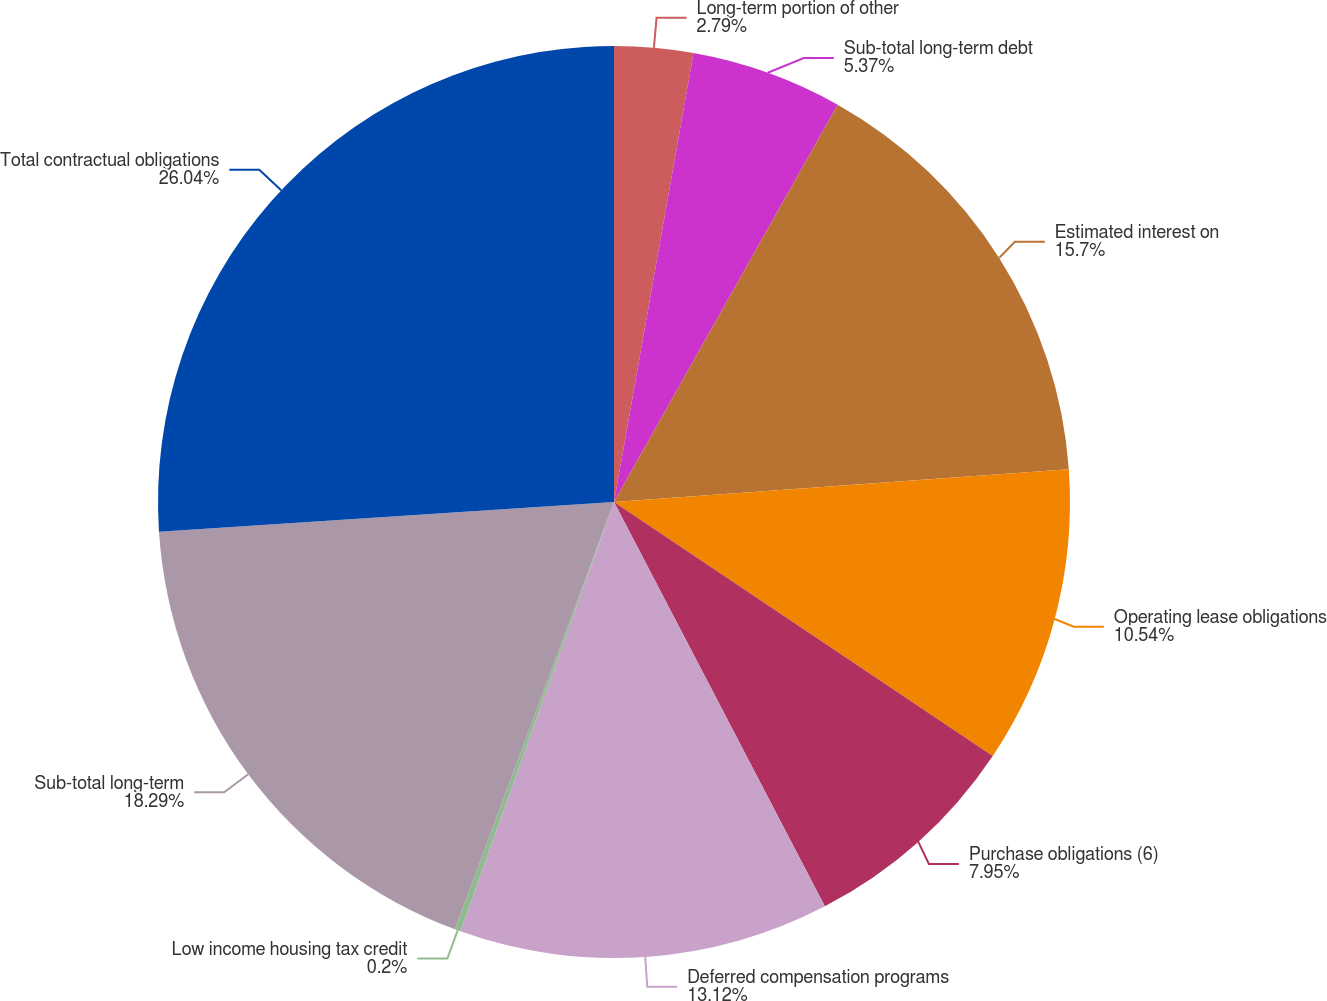<chart> <loc_0><loc_0><loc_500><loc_500><pie_chart><fcel>Long-term portion of other<fcel>Sub-total long-term debt<fcel>Estimated interest on<fcel>Operating lease obligations<fcel>Purchase obligations (6)<fcel>Deferred compensation programs<fcel>Low income housing tax credit<fcel>Sub-total long-term<fcel>Total contractual obligations<nl><fcel>2.79%<fcel>5.37%<fcel>15.7%<fcel>10.54%<fcel>7.95%<fcel>13.12%<fcel>0.2%<fcel>18.29%<fcel>26.04%<nl></chart> 